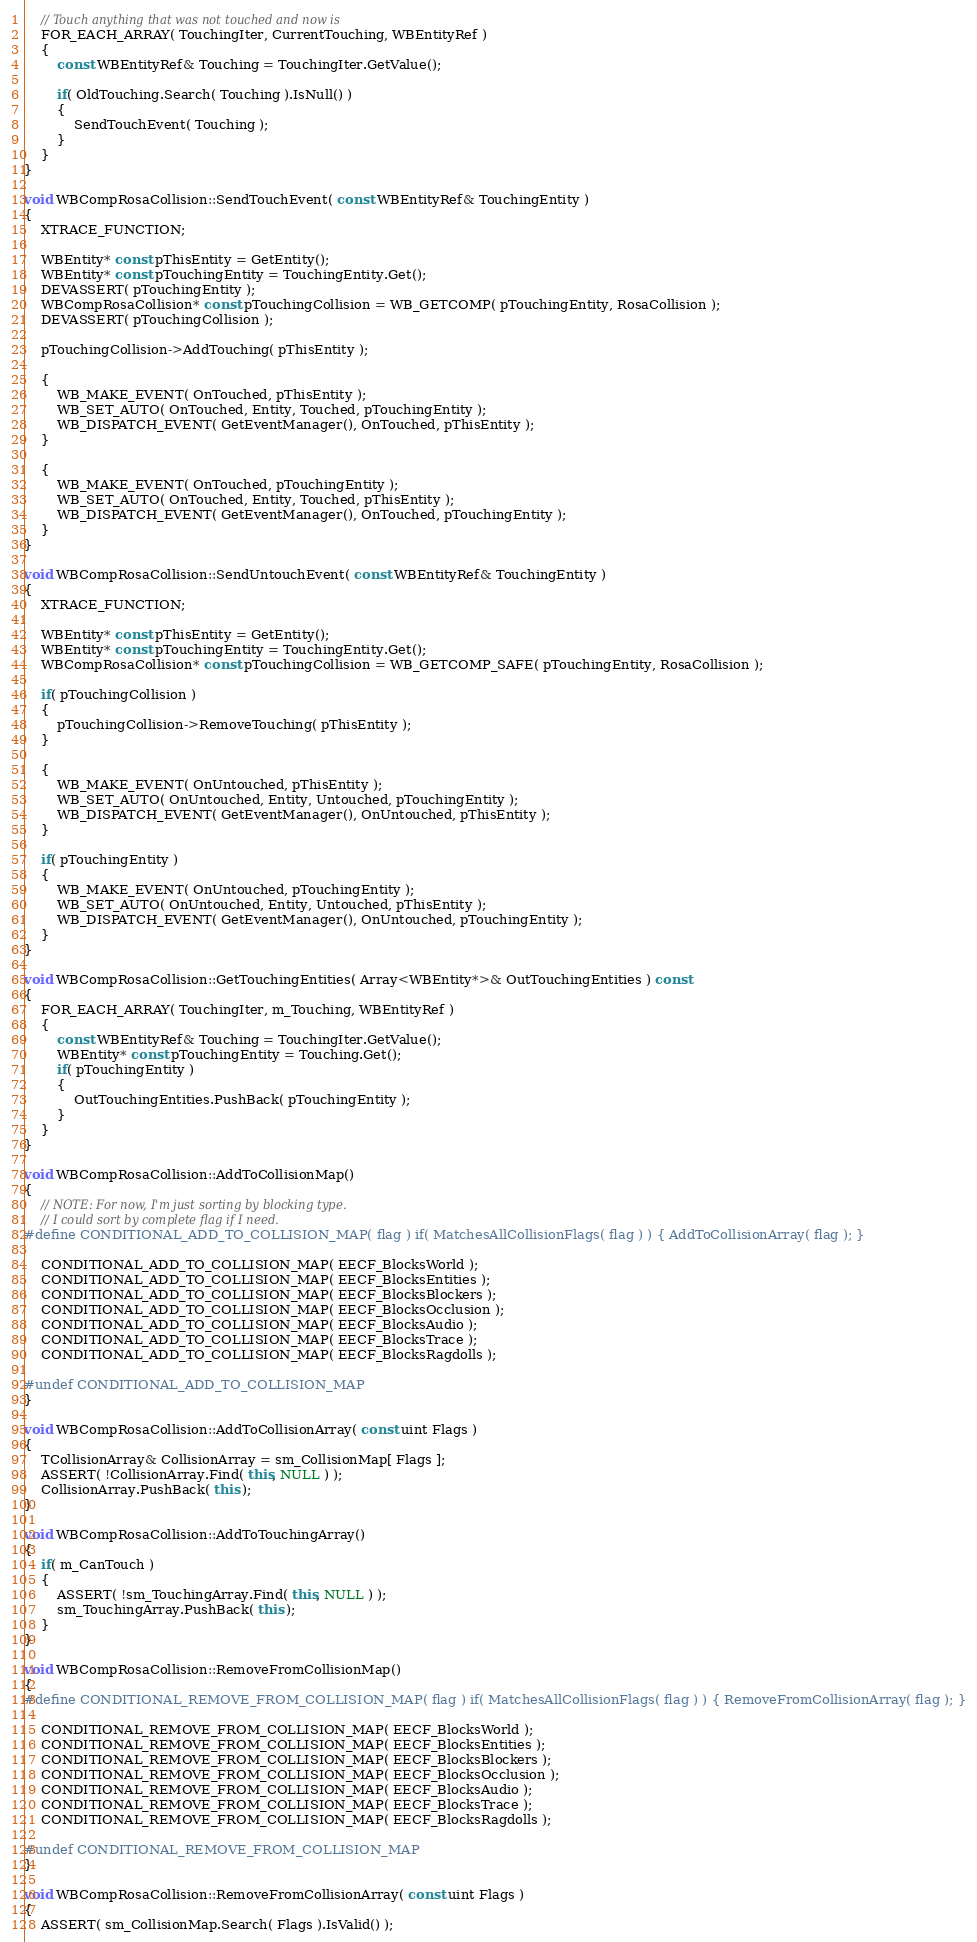<code> <loc_0><loc_0><loc_500><loc_500><_C++_>	// Touch anything that was not touched and now is
	FOR_EACH_ARRAY( TouchingIter, CurrentTouching, WBEntityRef )
	{
		const WBEntityRef& Touching = TouchingIter.GetValue();

		if( OldTouching.Search( Touching ).IsNull() )
		{
			SendTouchEvent( Touching );
		}
	}
}

void WBCompRosaCollision::SendTouchEvent( const WBEntityRef& TouchingEntity )
{
	XTRACE_FUNCTION;

	WBEntity* const pThisEntity = GetEntity();
	WBEntity* const pTouchingEntity = TouchingEntity.Get();
	DEVASSERT( pTouchingEntity );
	WBCompRosaCollision* const pTouchingCollision = WB_GETCOMP( pTouchingEntity, RosaCollision );
	DEVASSERT( pTouchingCollision );

	pTouchingCollision->AddTouching( pThisEntity );

	{
		WB_MAKE_EVENT( OnTouched, pThisEntity );
		WB_SET_AUTO( OnTouched, Entity, Touched, pTouchingEntity );
		WB_DISPATCH_EVENT( GetEventManager(), OnTouched, pThisEntity );
	}

	{
		WB_MAKE_EVENT( OnTouched, pTouchingEntity );
		WB_SET_AUTO( OnTouched, Entity, Touched, pThisEntity );
		WB_DISPATCH_EVENT( GetEventManager(), OnTouched, pTouchingEntity );
	}
}

void WBCompRosaCollision::SendUntouchEvent( const WBEntityRef& TouchingEntity )
{
	XTRACE_FUNCTION;

	WBEntity* const pThisEntity = GetEntity();
	WBEntity* const pTouchingEntity = TouchingEntity.Get();
	WBCompRosaCollision* const pTouchingCollision = WB_GETCOMP_SAFE( pTouchingEntity, RosaCollision );

	if( pTouchingCollision )
	{
		pTouchingCollision->RemoveTouching( pThisEntity );
	}

	{
		WB_MAKE_EVENT( OnUntouched, pThisEntity );
		WB_SET_AUTO( OnUntouched, Entity, Untouched, pTouchingEntity );
		WB_DISPATCH_EVENT( GetEventManager(), OnUntouched, pThisEntity );
	}

	if( pTouchingEntity )
	{
		WB_MAKE_EVENT( OnUntouched, pTouchingEntity );
		WB_SET_AUTO( OnUntouched, Entity, Untouched, pThisEntity );
		WB_DISPATCH_EVENT( GetEventManager(), OnUntouched, pTouchingEntity );
	}
}

void WBCompRosaCollision::GetTouchingEntities( Array<WBEntity*>& OutTouchingEntities ) const
{
	FOR_EACH_ARRAY( TouchingIter, m_Touching, WBEntityRef )
	{
		const WBEntityRef& Touching = TouchingIter.GetValue();
		WBEntity* const pTouchingEntity = Touching.Get();
		if( pTouchingEntity )
		{
			OutTouchingEntities.PushBack( pTouchingEntity );
		}
	}
}

void WBCompRosaCollision::AddToCollisionMap()
{
	// NOTE: For now, I'm just sorting by blocking type.
	// I could sort by complete flag if I need.
#define CONDITIONAL_ADD_TO_COLLISION_MAP( flag ) if( MatchesAllCollisionFlags( flag ) ) { AddToCollisionArray( flag ); }

	CONDITIONAL_ADD_TO_COLLISION_MAP( EECF_BlocksWorld );
	CONDITIONAL_ADD_TO_COLLISION_MAP( EECF_BlocksEntities );
	CONDITIONAL_ADD_TO_COLLISION_MAP( EECF_BlocksBlockers );
	CONDITIONAL_ADD_TO_COLLISION_MAP( EECF_BlocksOcclusion );
	CONDITIONAL_ADD_TO_COLLISION_MAP( EECF_BlocksAudio );
	CONDITIONAL_ADD_TO_COLLISION_MAP( EECF_BlocksTrace );
	CONDITIONAL_ADD_TO_COLLISION_MAP( EECF_BlocksRagdolls );

#undef CONDITIONAL_ADD_TO_COLLISION_MAP
}

void WBCompRosaCollision::AddToCollisionArray( const uint Flags )
{
	TCollisionArray& CollisionArray = sm_CollisionMap[ Flags ];
	ASSERT( !CollisionArray.Find( this, NULL ) );
	CollisionArray.PushBack( this );
}

void WBCompRosaCollision::AddToTouchingArray()
{
	if( m_CanTouch )
	{
		ASSERT( !sm_TouchingArray.Find( this, NULL ) );
		sm_TouchingArray.PushBack( this );
	}
}

void WBCompRosaCollision::RemoveFromCollisionMap()
{
#define CONDITIONAL_REMOVE_FROM_COLLISION_MAP( flag ) if( MatchesAllCollisionFlags( flag ) ) { RemoveFromCollisionArray( flag ); }

	CONDITIONAL_REMOVE_FROM_COLLISION_MAP( EECF_BlocksWorld );
	CONDITIONAL_REMOVE_FROM_COLLISION_MAP( EECF_BlocksEntities );
	CONDITIONAL_REMOVE_FROM_COLLISION_MAP( EECF_BlocksBlockers );
	CONDITIONAL_REMOVE_FROM_COLLISION_MAP( EECF_BlocksOcclusion );
	CONDITIONAL_REMOVE_FROM_COLLISION_MAP( EECF_BlocksAudio );
	CONDITIONAL_REMOVE_FROM_COLLISION_MAP( EECF_BlocksTrace );
	CONDITIONAL_REMOVE_FROM_COLLISION_MAP( EECF_BlocksRagdolls );

#undef CONDITIONAL_REMOVE_FROM_COLLISION_MAP
}

void WBCompRosaCollision::RemoveFromCollisionArray( const uint Flags )
{
	ASSERT( sm_CollisionMap.Search( Flags ).IsValid() );</code> 